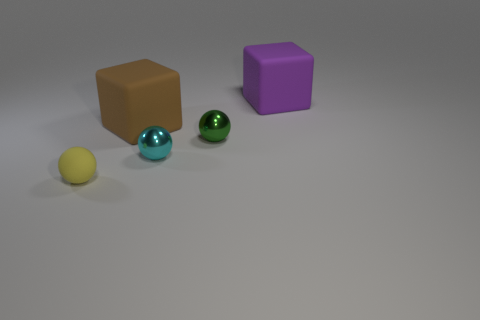Subtract all green metal spheres. How many spheres are left? 2 Add 2 tiny gray shiny blocks. How many objects exist? 7 Subtract all yellow balls. How many balls are left? 2 Subtract all cubes. How many objects are left? 3 Subtract 3 balls. How many balls are left? 0 Subtract all purple cubes. Subtract all yellow cylinders. How many cubes are left? 1 Subtract all tiny yellow spheres. Subtract all yellow rubber objects. How many objects are left? 3 Add 5 yellow balls. How many yellow balls are left? 6 Add 1 blue matte balls. How many blue matte balls exist? 1 Subtract 0 gray cylinders. How many objects are left? 5 